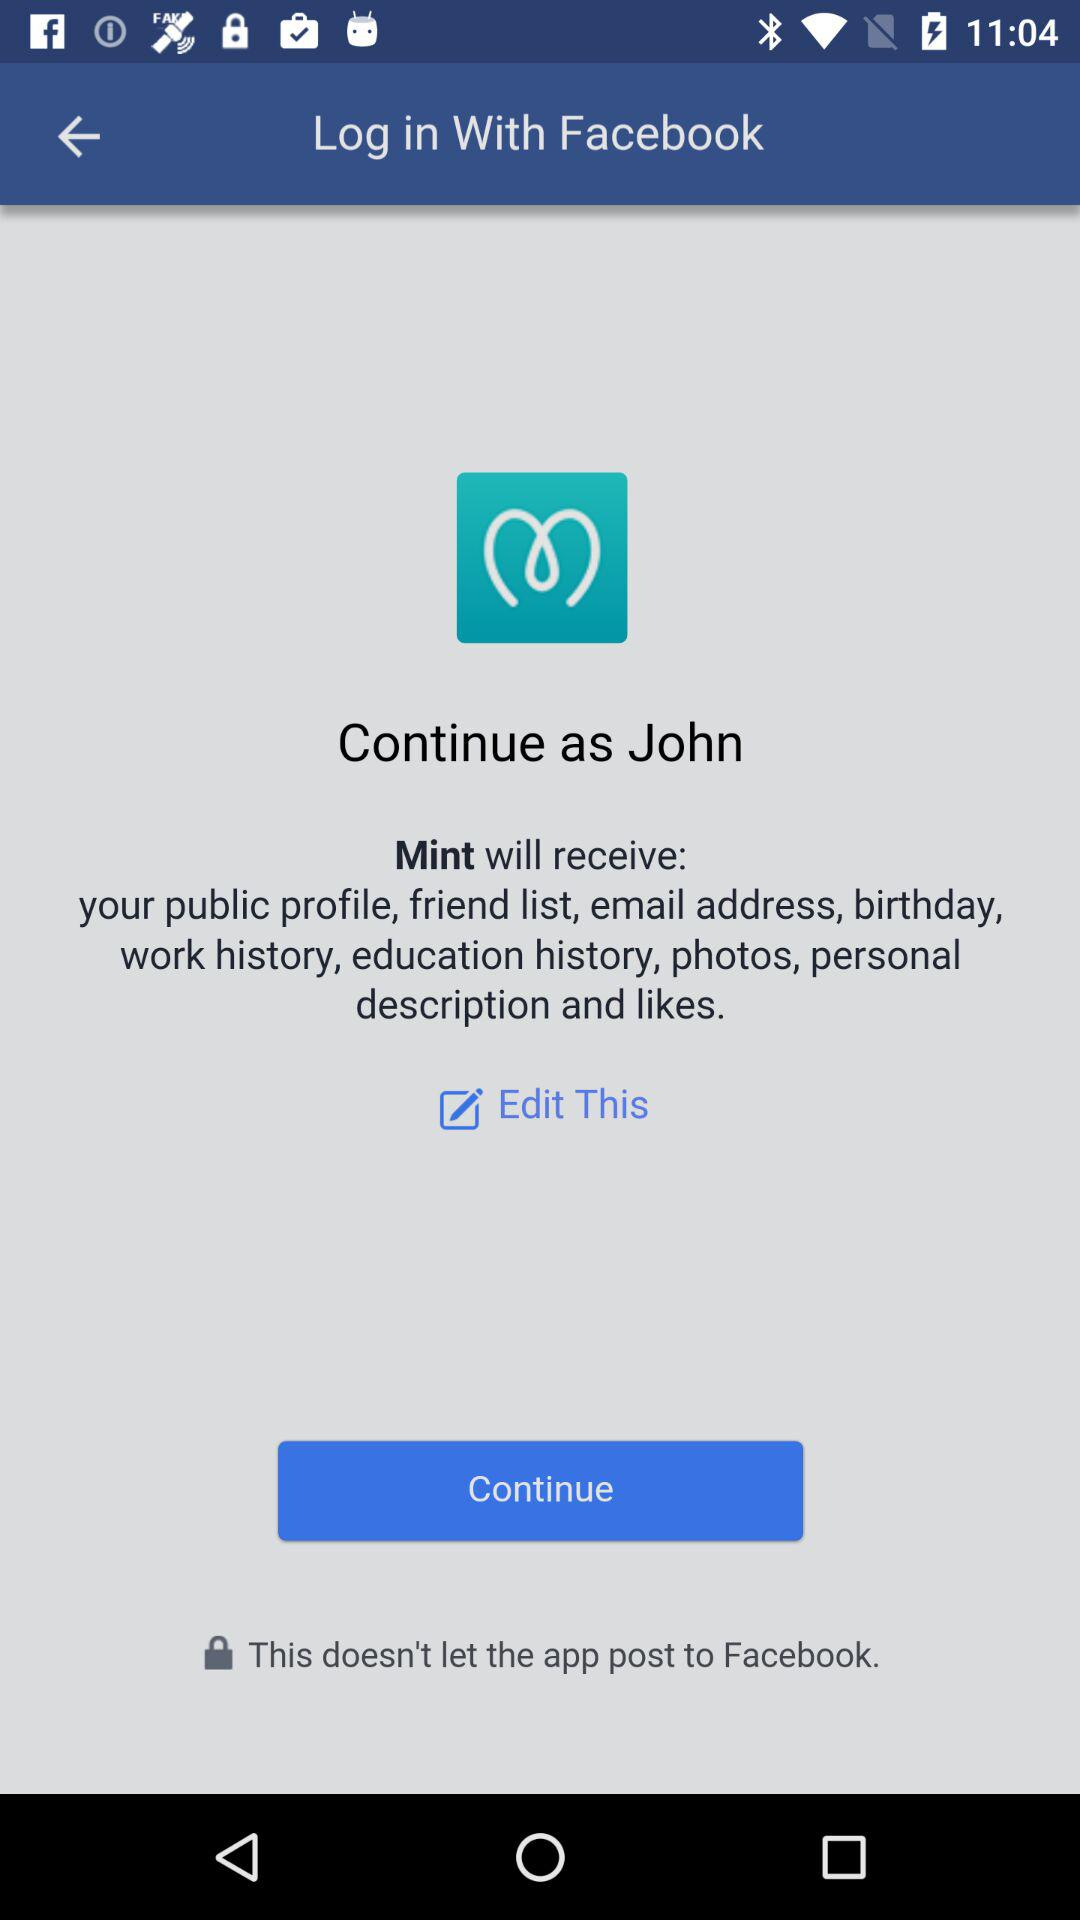What is the user name? The user name is "John". 